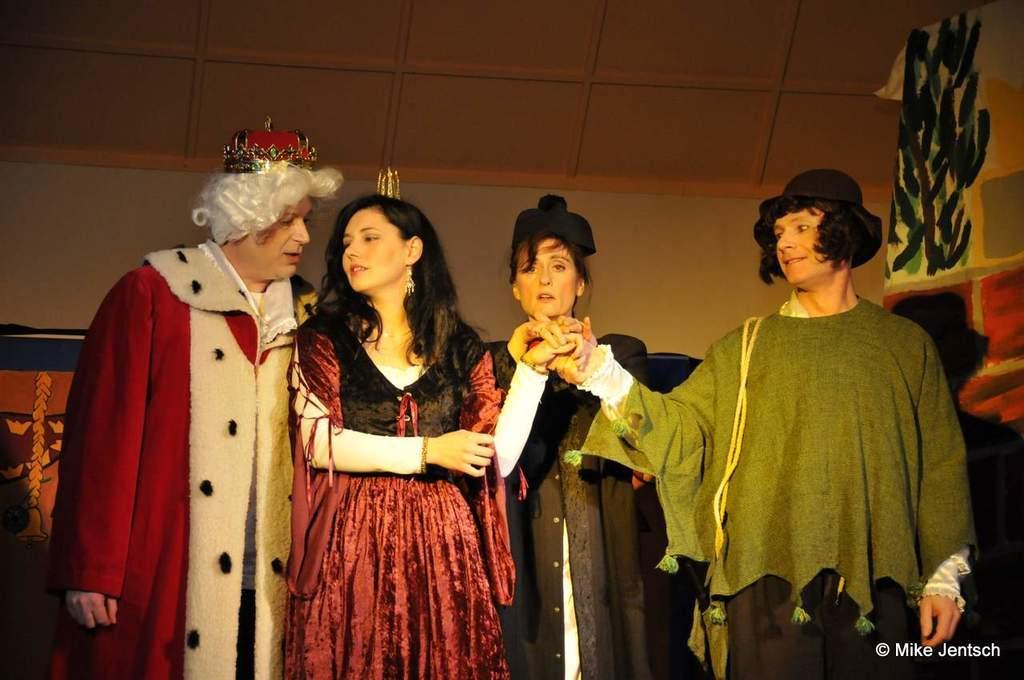Describe this image in one or two sentences. In the picture I can see a four persons. I can see a woman in the middle of the picture and she is holding the hand of a man who is on the right side. I can see a man on the left side and looks like he is having a conversation with a woman next to him. 